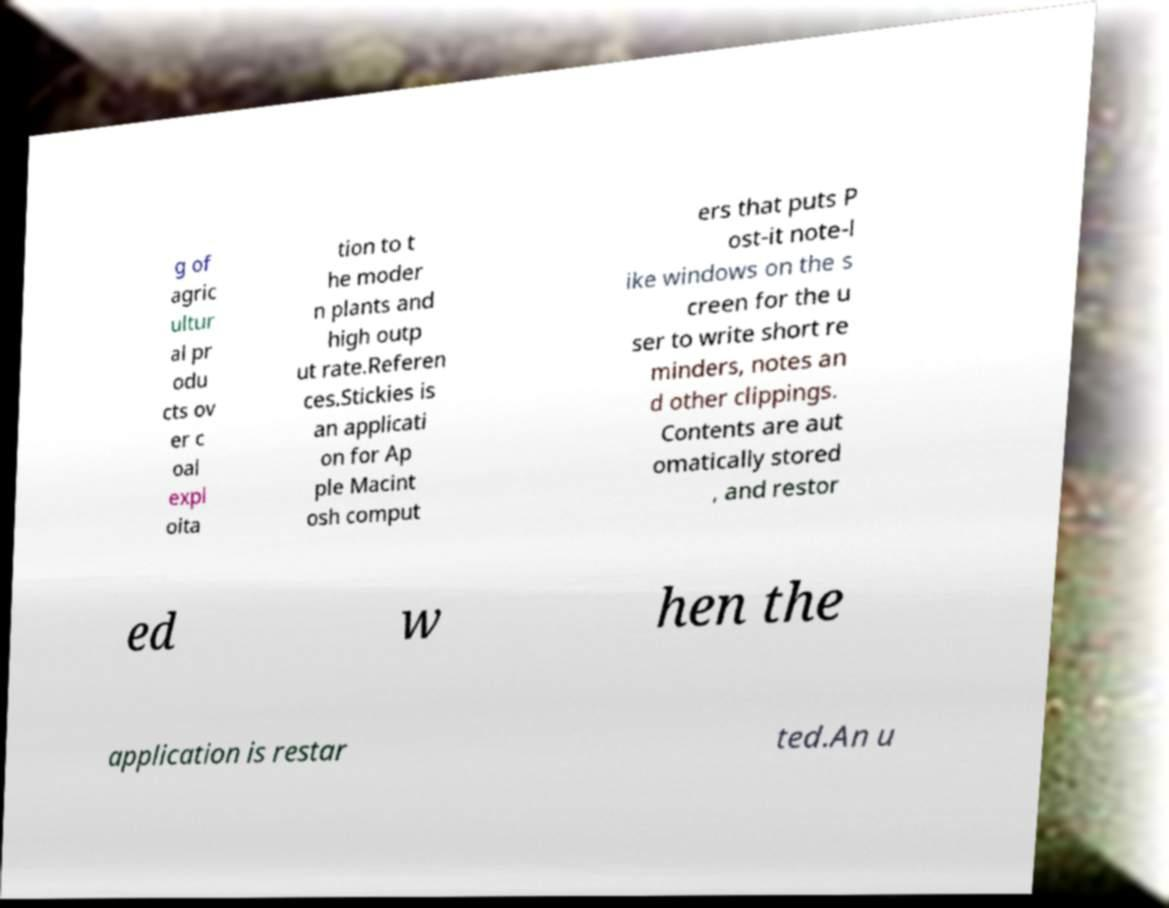Please read and relay the text visible in this image. What does it say? g of agric ultur al pr odu cts ov er c oal expl oita tion to t he moder n plants and high outp ut rate.Referen ces.Stickies is an applicati on for Ap ple Macint osh comput ers that puts P ost-it note-l ike windows on the s creen for the u ser to write short re minders, notes an d other clippings. Contents are aut omatically stored , and restor ed w hen the application is restar ted.An u 